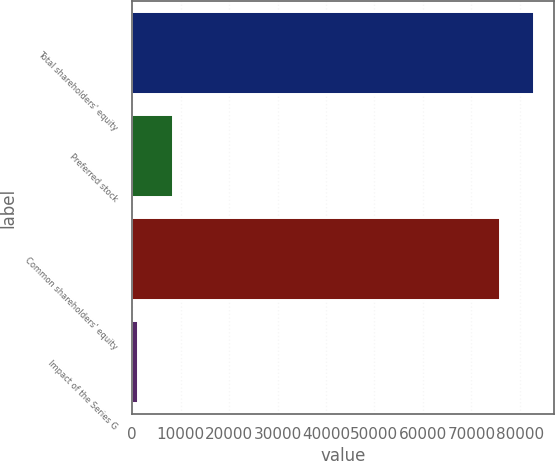<chart> <loc_0><loc_0><loc_500><loc_500><bar_chart><fcel>Total shareholders' equity<fcel>Preferred stock<fcel>Common shareholders' equity<fcel>Impact of the Series G<nl><fcel>83006.8<fcel>8408.4<fcel>75862.4<fcel>1264<nl></chart> 